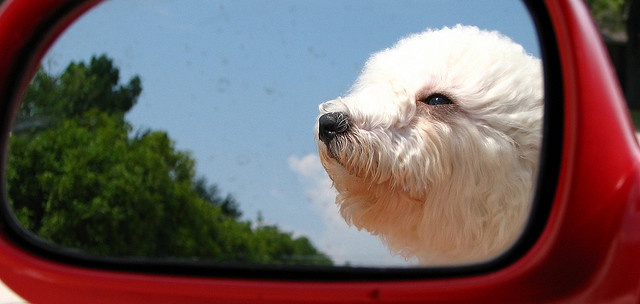Describe the objects in this image and their specific colors. I can see a dog in black, gray, white, and darkgray tones in this image. 